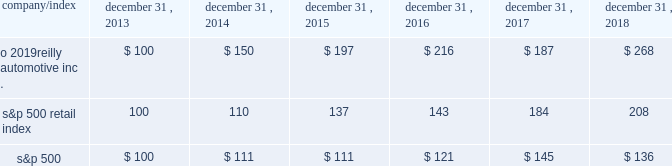Stock performance graph : the graph below shows the cumulative total shareholder return assuming the investment of $ 100 , on december 31 , 2013 , and the reinvestment of dividends thereafter , if any , in the company 2019s common stock versus the standard and poor 2019s s&p 500 retail index ( 201cs&p 500 retail index 201d ) and the standard and poor 2019s s&p 500 index ( 201cs&p 500 201d ) . .

What is the roi of an investment in o 2019reilly automotive inc . from 2013 to 2017? 
Computations: ((187 - 100) / 100)
Answer: 0.87. 